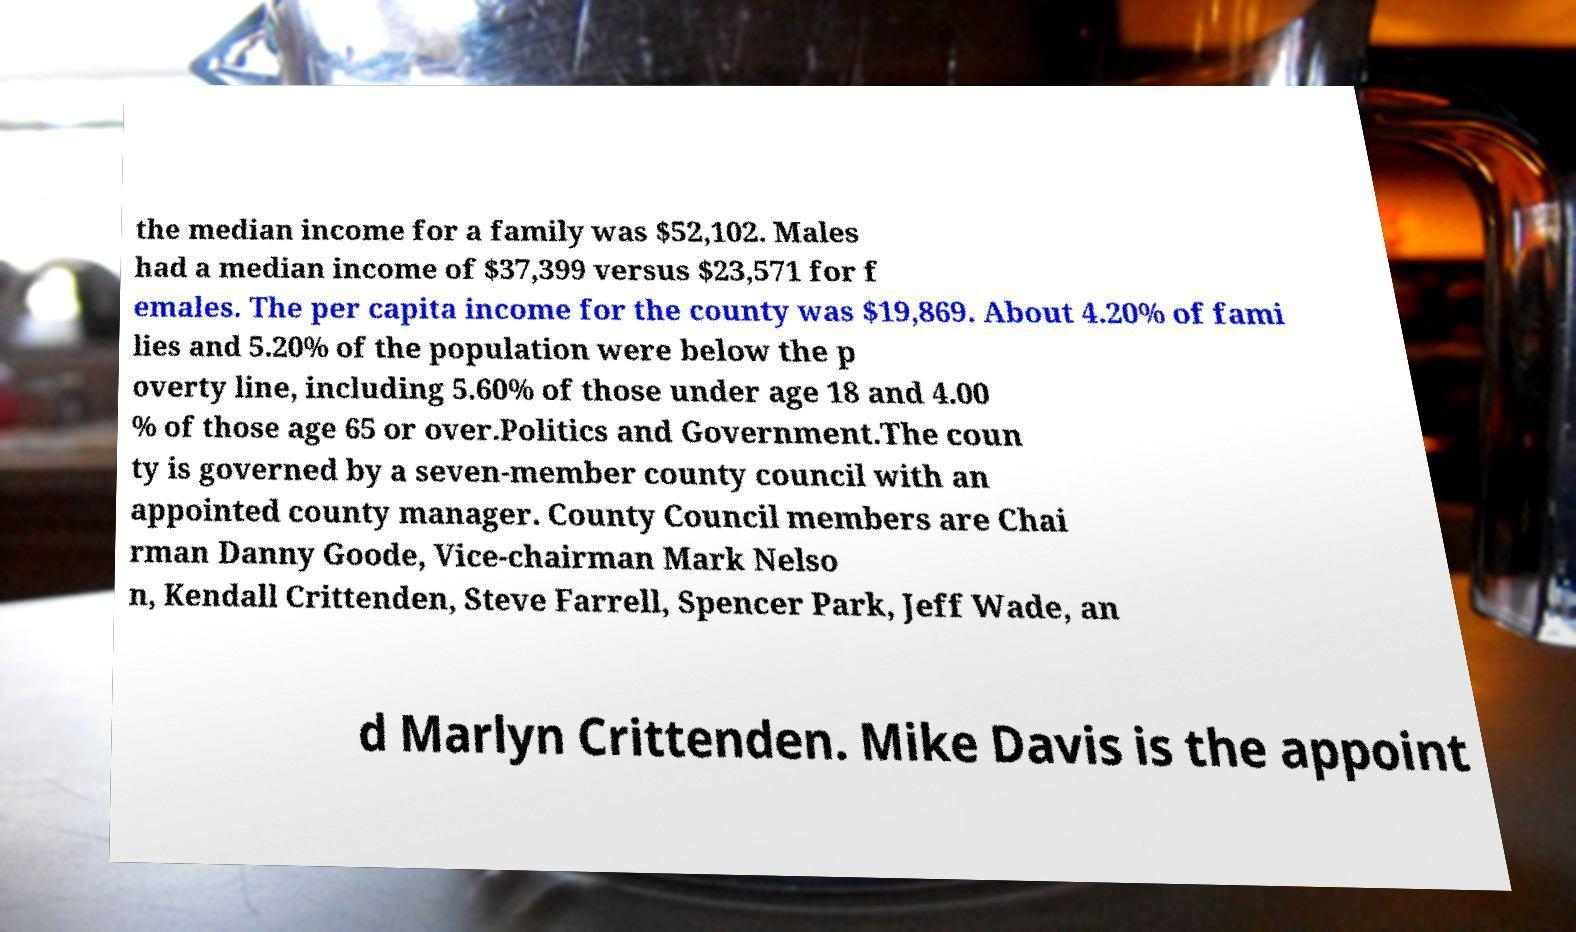I need the written content from this picture converted into text. Can you do that? the median income for a family was $52,102. Males had a median income of $37,399 versus $23,571 for f emales. The per capita income for the county was $19,869. About 4.20% of fami lies and 5.20% of the population were below the p overty line, including 5.60% of those under age 18 and 4.00 % of those age 65 or over.Politics and Government.The coun ty is governed by a seven-member county council with an appointed county manager. County Council members are Chai rman Danny Goode, Vice-chairman Mark Nelso n, Kendall Crittenden, Steve Farrell, Spencer Park, Jeff Wade, an d Marlyn Crittenden. Mike Davis is the appoint 